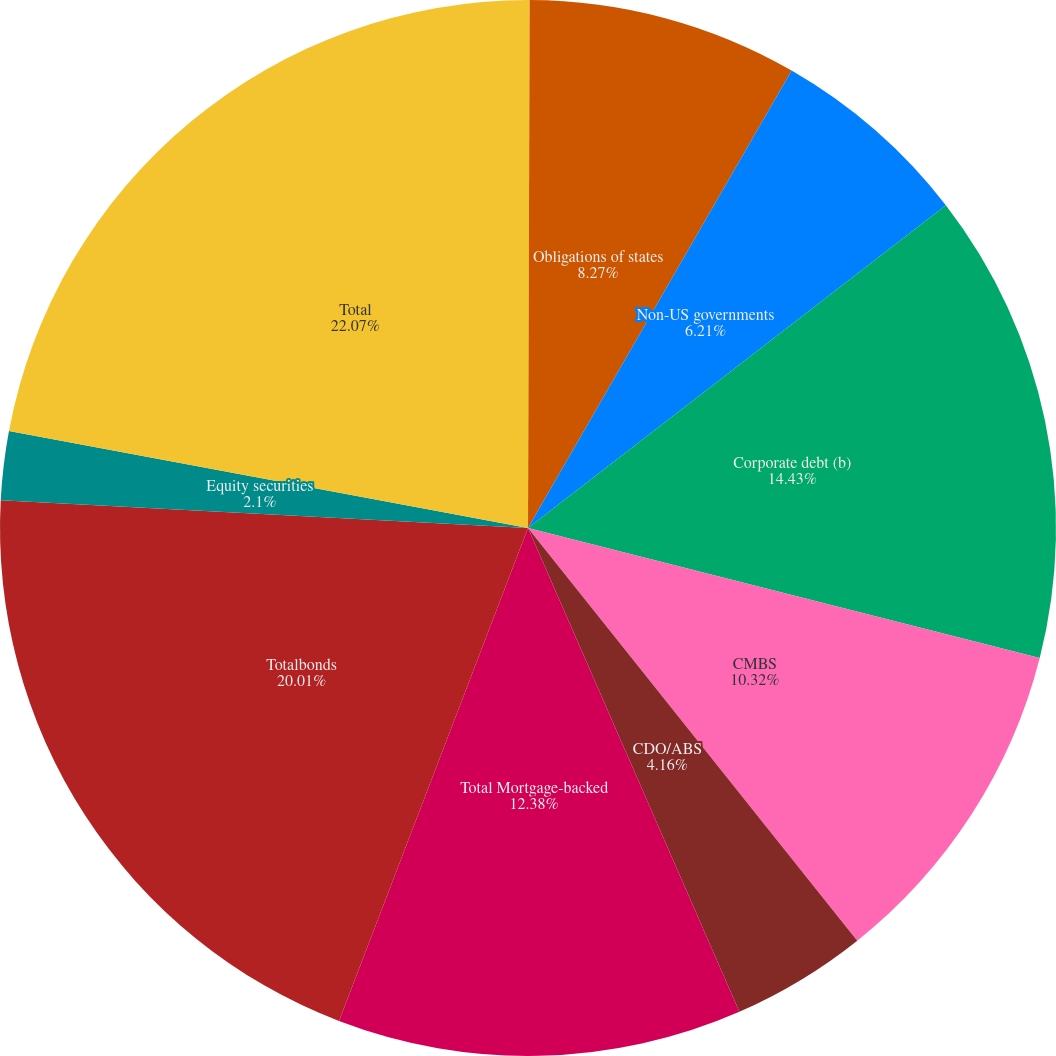Convert chart to OTSL. <chart><loc_0><loc_0><loc_500><loc_500><pie_chart><fcel>US government and government<fcel>Obligations of states<fcel>Non-US governments<fcel>Corporate debt (b)<fcel>CMBS<fcel>CDO/ABS<fcel>Total Mortgage-backed<fcel>Totalbonds<fcel>Equity securities<fcel>Total<nl><fcel>0.05%<fcel>8.27%<fcel>6.21%<fcel>14.43%<fcel>10.32%<fcel>4.16%<fcel>12.38%<fcel>20.01%<fcel>2.1%<fcel>22.06%<nl></chart> 